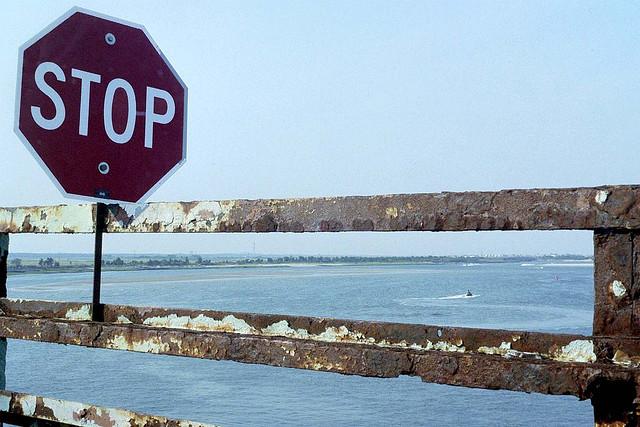What kind of sign is this?
Write a very short answer. Stop. Is the body of water a lake or ocean?
Answer briefly. Lake. What are the colors that stop sign has?
Answer briefly. Red and white. 